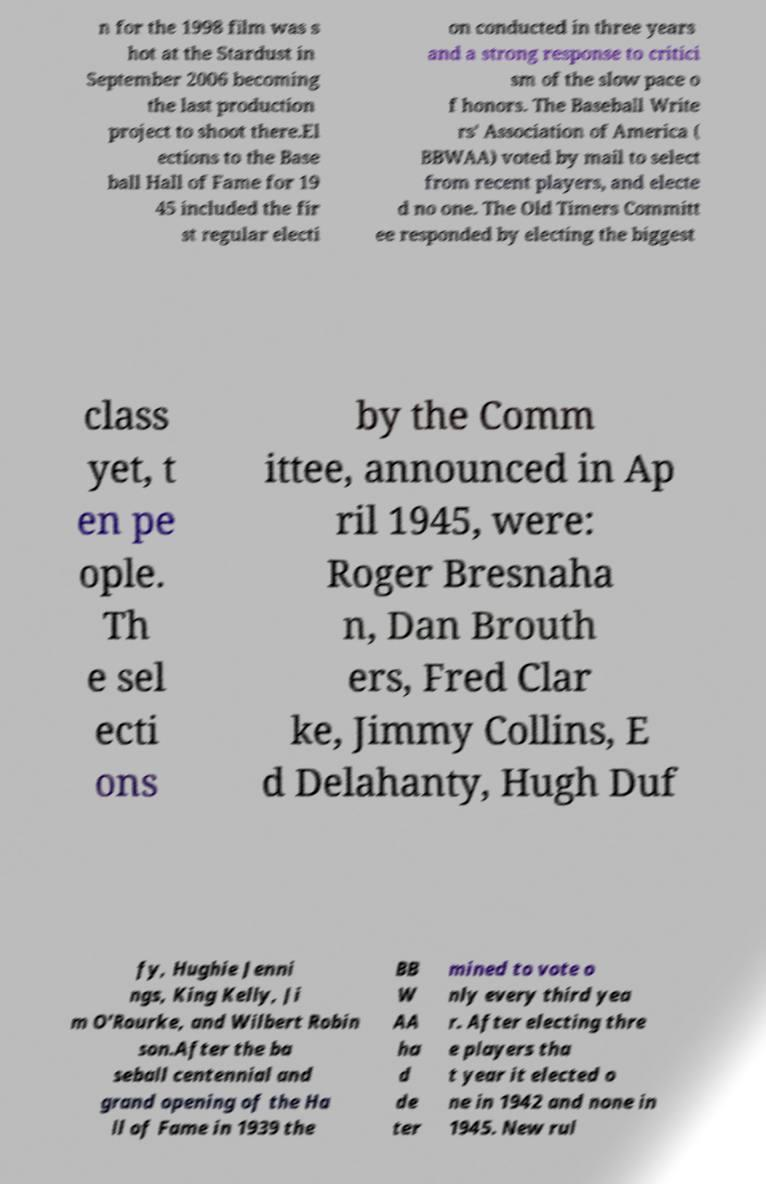I need the written content from this picture converted into text. Can you do that? n for the 1998 film was s hot at the Stardust in September 2006 becoming the last production project to shoot there.El ections to the Base ball Hall of Fame for 19 45 included the fir st regular electi on conducted in three years and a strong response to critici sm of the slow pace o f honors. The Baseball Write rs' Association of America ( BBWAA) voted by mail to select from recent players, and electe d no one. The Old Timers Committ ee responded by electing the biggest class yet, t en pe ople. Th e sel ecti ons by the Comm ittee, announced in Ap ril 1945, were: Roger Bresnaha n, Dan Brouth ers, Fred Clar ke, Jimmy Collins, E d Delahanty, Hugh Duf fy, Hughie Jenni ngs, King Kelly, Ji m O'Rourke, and Wilbert Robin son.After the ba seball centennial and grand opening of the Ha ll of Fame in 1939 the BB W AA ha d de ter mined to vote o nly every third yea r. After electing thre e players tha t year it elected o ne in 1942 and none in 1945. New rul 